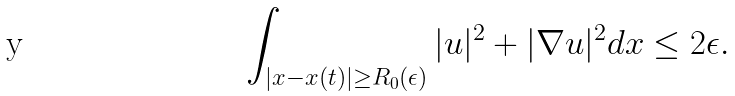<formula> <loc_0><loc_0><loc_500><loc_500>\int _ { | x - x ( t ) | \geq R _ { 0 } ( \epsilon ) } | u | ^ { 2 } + | \nabla u | ^ { 2 } d x \leq 2 \epsilon .</formula> 